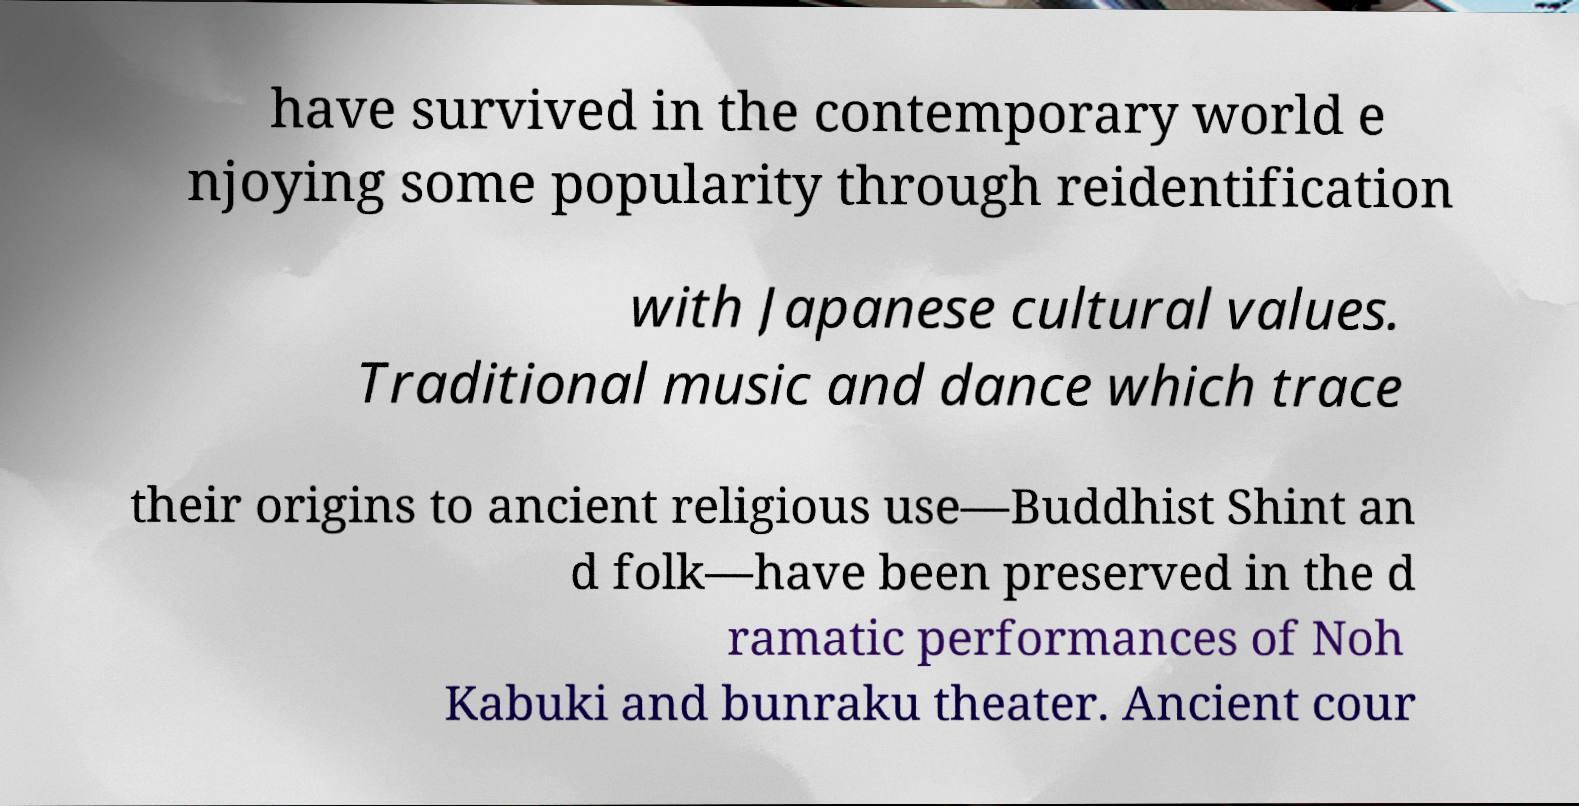What messages or text are displayed in this image? I need them in a readable, typed format. have survived in the contemporary world e njoying some popularity through reidentification with Japanese cultural values. Traditional music and dance which trace their origins to ancient religious use—Buddhist Shint an d folk—have been preserved in the d ramatic performances of Noh Kabuki and bunraku theater. Ancient cour 